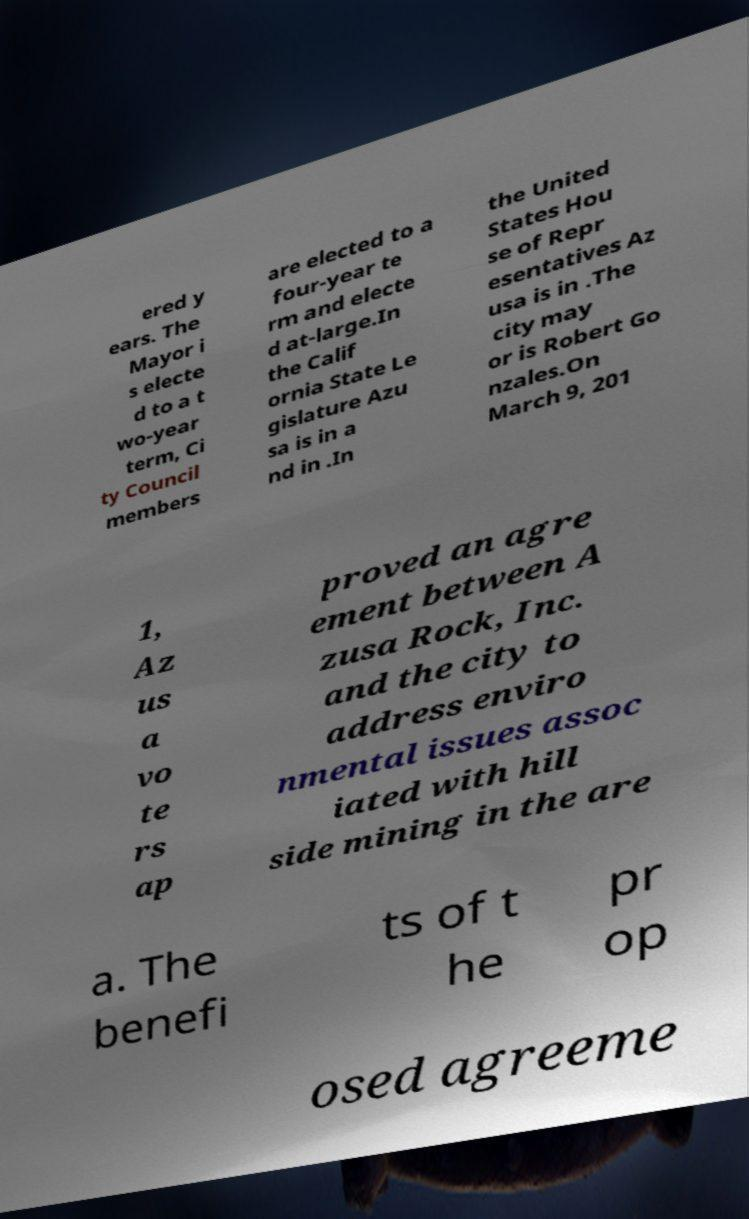I need the written content from this picture converted into text. Can you do that? ered y ears. The Mayor i s electe d to a t wo-year term, Ci ty Council members are elected to a four-year te rm and electe d at-large.In the Calif ornia State Le gislature Azu sa is in a nd in .In the United States Hou se of Repr esentatives Az usa is in .The city may or is Robert Go nzales.On March 9, 201 1, Az us a vo te rs ap proved an agre ement between A zusa Rock, Inc. and the city to address enviro nmental issues assoc iated with hill side mining in the are a. The benefi ts of t he pr op osed agreeme 